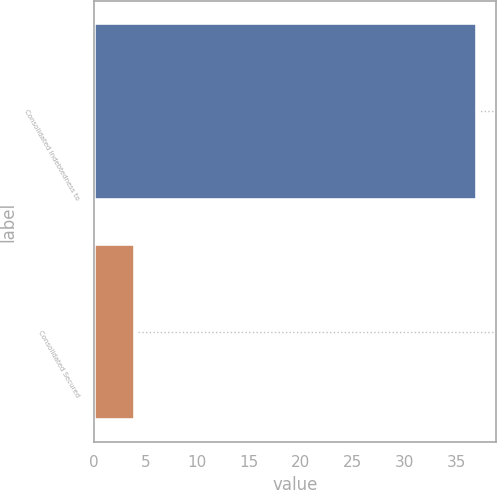Convert chart. <chart><loc_0><loc_0><loc_500><loc_500><bar_chart><fcel>Consolidated Indebtedness to<fcel>Consolidated Secured<nl><fcel>37<fcel>4<nl></chart> 